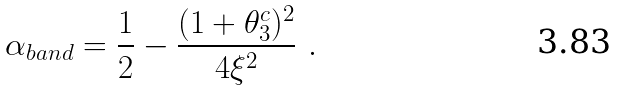Convert formula to latex. <formula><loc_0><loc_0><loc_500><loc_500>\alpha _ { b a n d } = \frac { 1 } { 2 } - \frac { ( 1 + \theta _ { 3 } ^ { c } ) ^ { 2 } } { 4 \xi ^ { 2 } } \ .</formula> 